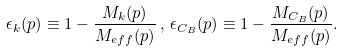Convert formula to latex. <formula><loc_0><loc_0><loc_500><loc_500>\epsilon _ { k } ( p ) \equiv 1 - \frac { M _ { k } ( p ) } { M _ { e f f } ( p ) } \, , \, \epsilon _ { C _ { B } } ( p ) \equiv 1 - \frac { M _ { C _ { B } } ( p ) } { M _ { e f f } ( p ) } .</formula> 